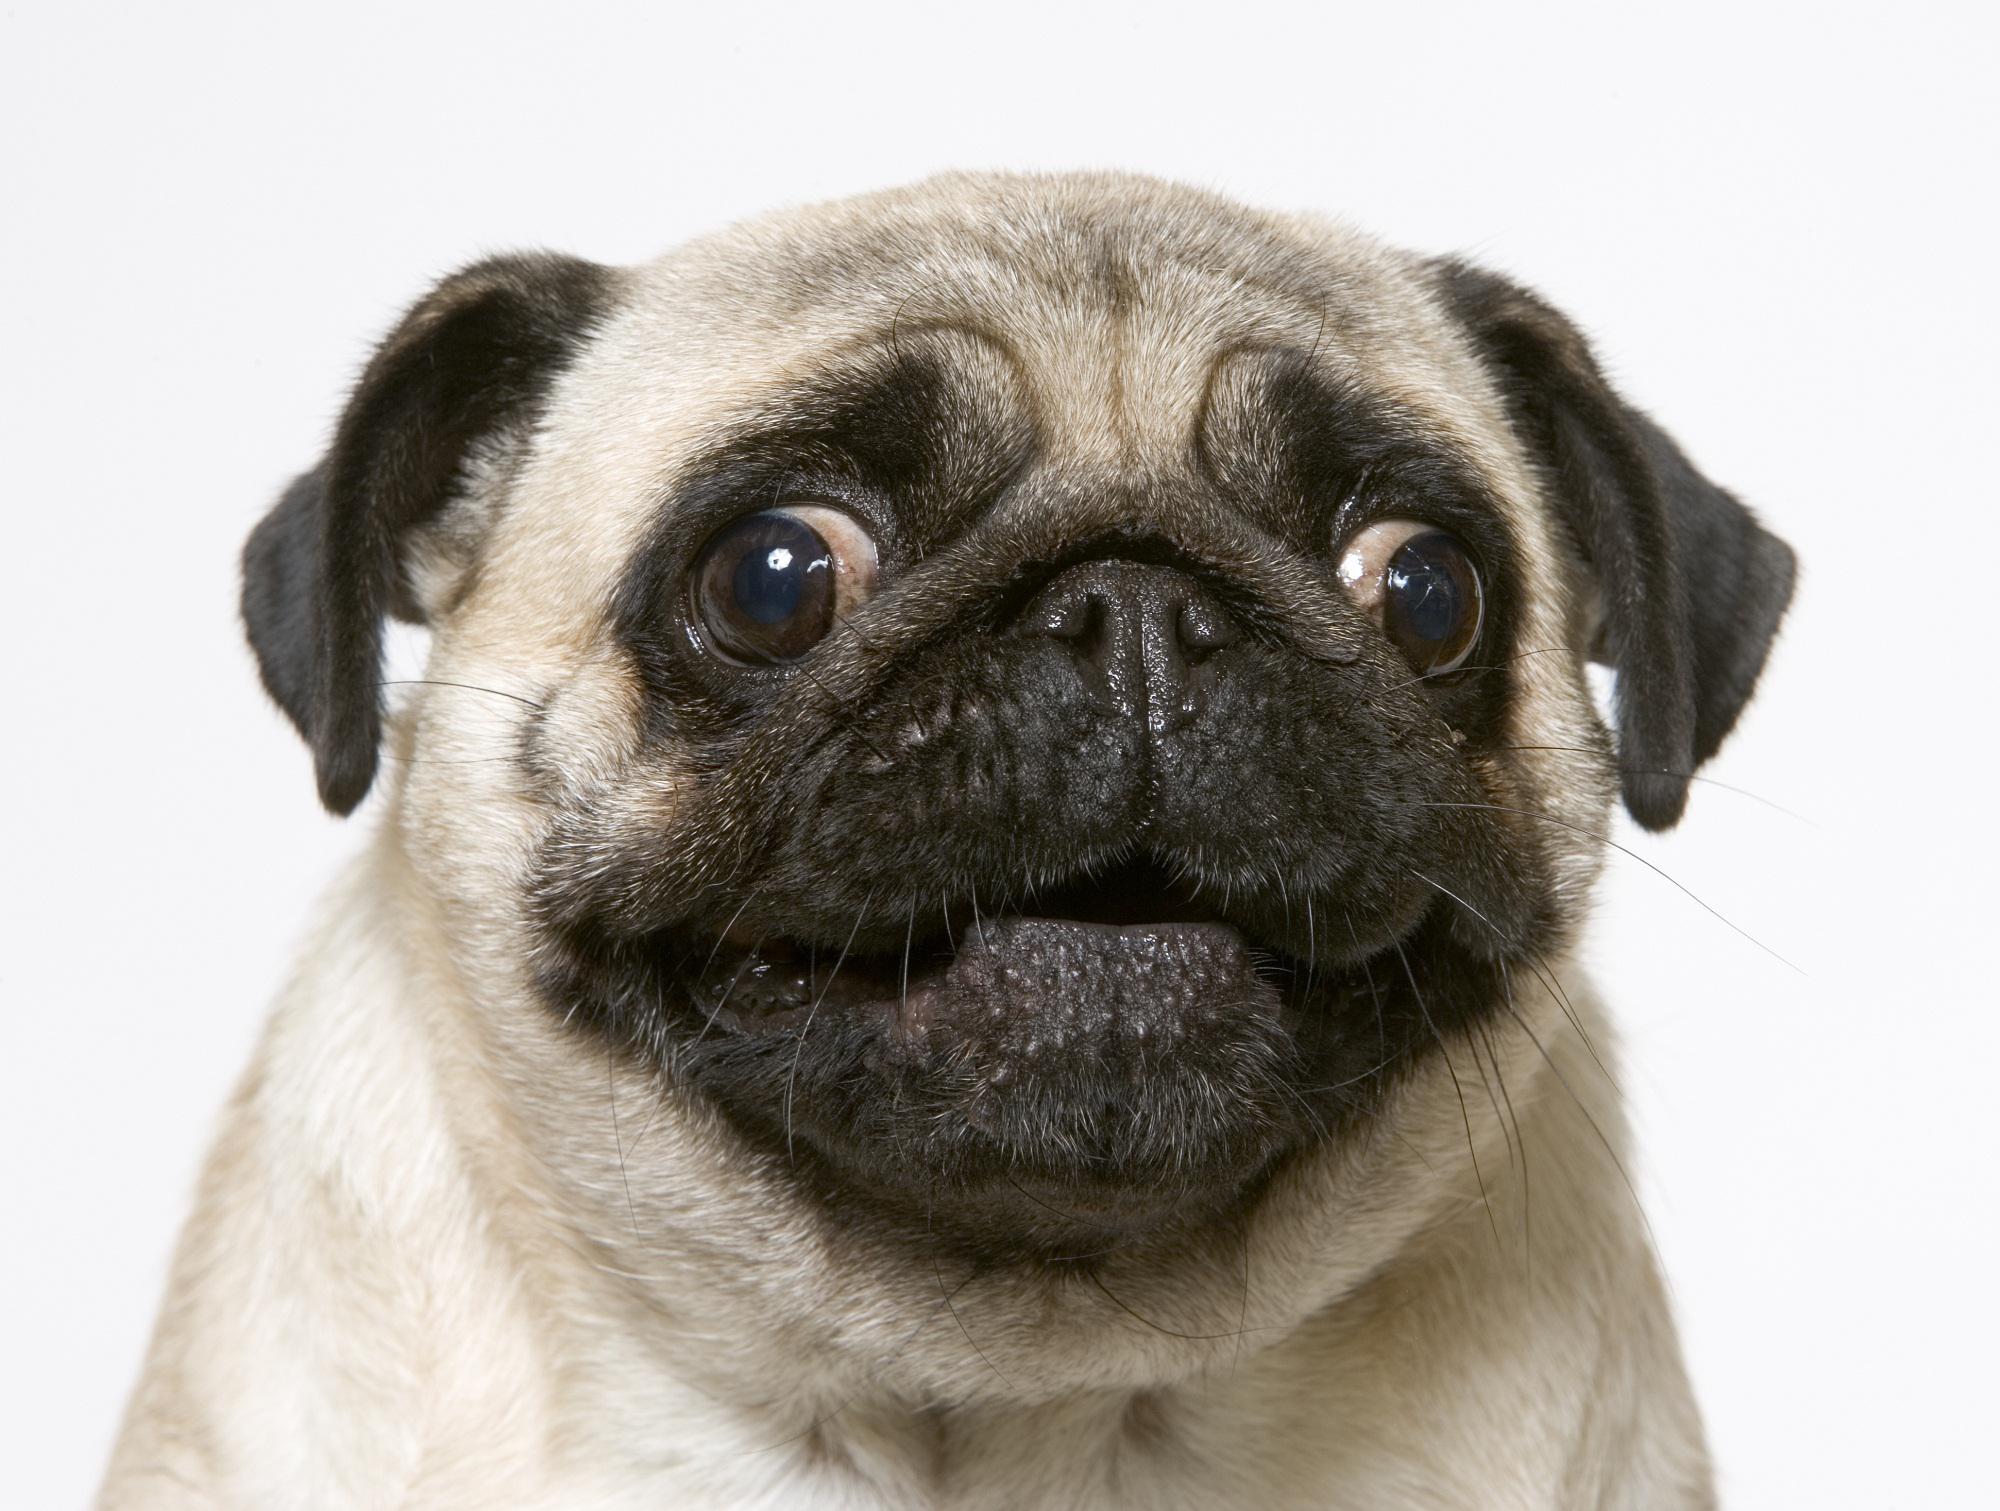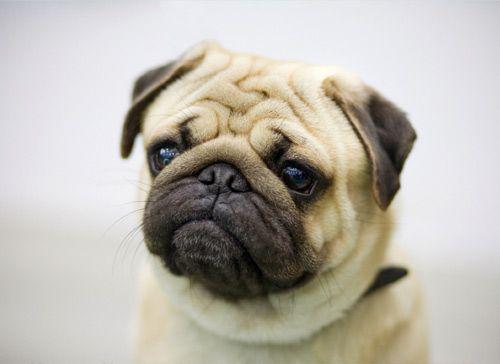The first image is the image on the left, the second image is the image on the right. Analyze the images presented: Is the assertion "Whites of the eyes are very visible on the dog on the left." valid? Answer yes or no. Yes. 